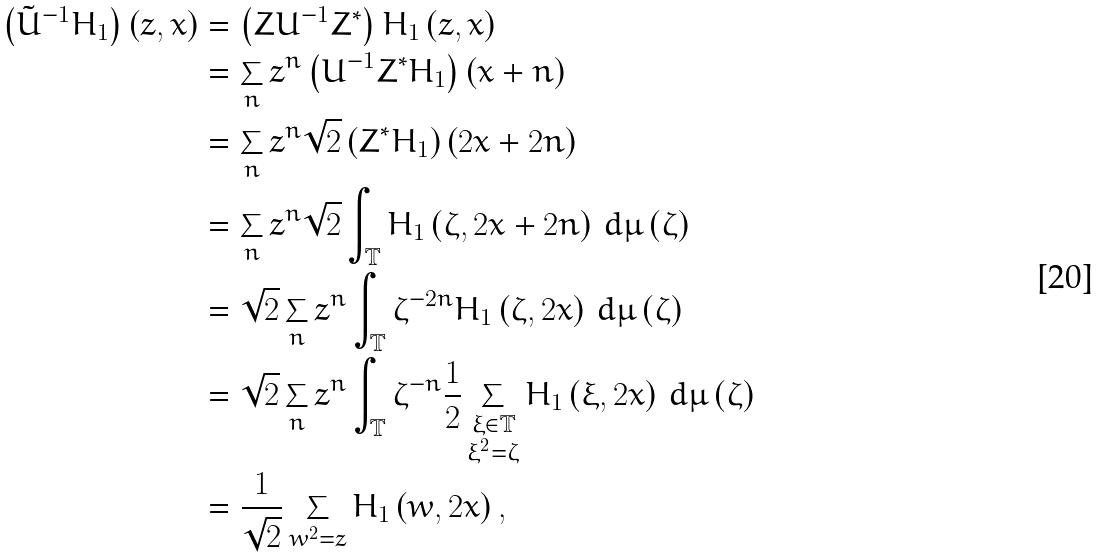Convert formula to latex. <formula><loc_0><loc_0><loc_500><loc_500>\left ( \tilde { U } ^ { - 1 } H _ { 1 } \right ) \left ( z , x \right ) & = \left ( Z U ^ { - 1 } Z ^ { \ast } \right ) H _ { 1 } \left ( z , x \right ) \\ & = \sum _ { n } z ^ { n } \left ( U ^ { - 1 } Z ^ { \ast } H _ { 1 } \right ) \left ( x + n \right ) \\ & = \sum _ { n } z ^ { n } \sqrt { 2 } \left ( Z ^ { \ast } H _ { 1 } \right ) \left ( 2 x + 2 n \right ) \\ & = \sum _ { n } z ^ { n } \sqrt { 2 } \int _ { \mathbb { T } } H _ { 1 } \left ( \zeta , 2 x + 2 n \right ) \, d \mu \left ( \zeta \right ) \\ & = \sqrt { 2 } \sum _ { n } z ^ { n } \int _ { \mathbb { T } } \zeta ^ { - 2 n } H _ { 1 } \left ( \zeta , 2 x \right ) \, d \mu \left ( \zeta \right ) \\ & = \sqrt { 2 } \sum _ { n } z ^ { n } \int _ { \mathbb { T } } \zeta ^ { - n } \frac { 1 } { 2 } \sum _ { \substack { \xi \in \mathbb { T } \\ \xi ^ { 2 } = \zeta } } H _ { 1 } \left ( \xi , 2 x \right ) \, d \mu \left ( \zeta \right ) \\ & = \frac { 1 } { \sqrt { 2 } } \sum _ { w ^ { 2 } = z } H _ { 1 } \left ( w , 2 x \right ) ,</formula> 